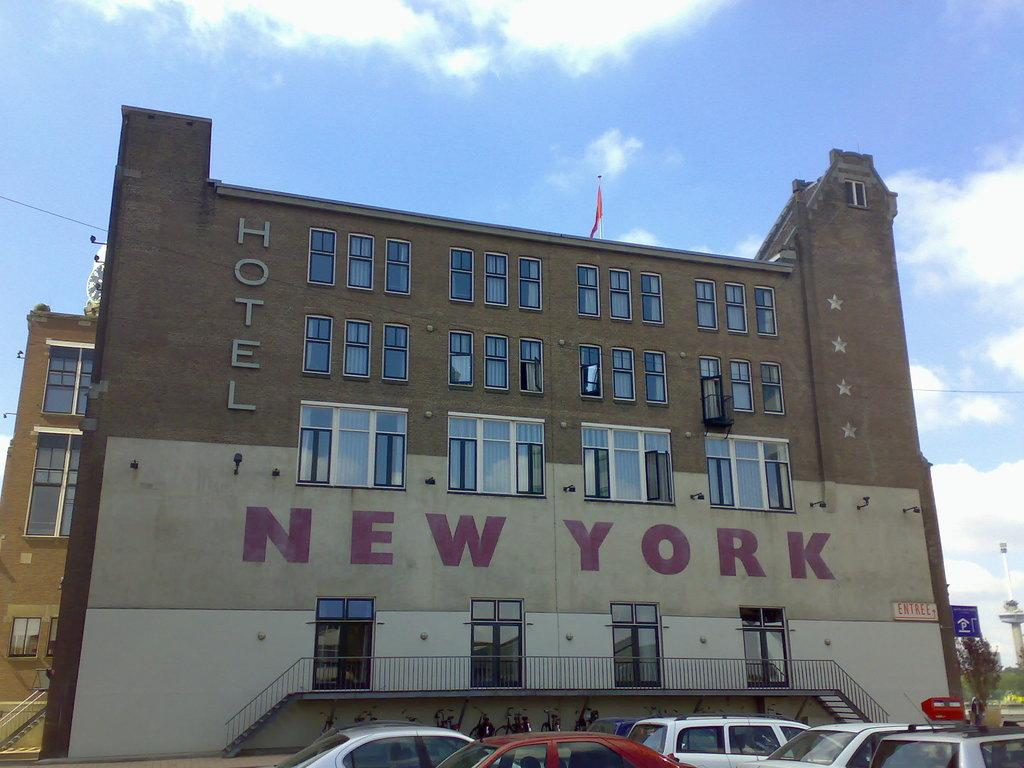What types of vehicles can be seen in the image? There are vehicles in the image, but the specific types are not mentioned. What are the name boards used for in the image? Name boards are present in the image, but their purpose is not specified. What is the fence made of in the image? The material of the fence is not mentioned in the provided facts. How many buildings with windows are visible in the image? Buildings with windows are visible in the image, but the exact number is not specified. What are the objects in the image? The objects in the image are not described in detail. What type of vegetation is present in the background of the image? Trees are present in the background of the image. What is visible in the sky in the image? Clouds are visible in the sky in the image. What is the rate of the notebook sliding down the slope in the image? There is no notebook or slope present in the image, so this question cannot be answered. 